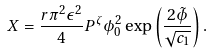Convert formula to latex. <formula><loc_0><loc_0><loc_500><loc_500>X = \frac { r \pi ^ { 2 } \epsilon ^ { 2 } } { 4 } P ^ { \zeta } \phi _ { 0 } ^ { 2 } \exp \left ( \frac { 2 \tilde { \phi } } { \sqrt { c _ { 1 } } } \right ) .</formula> 